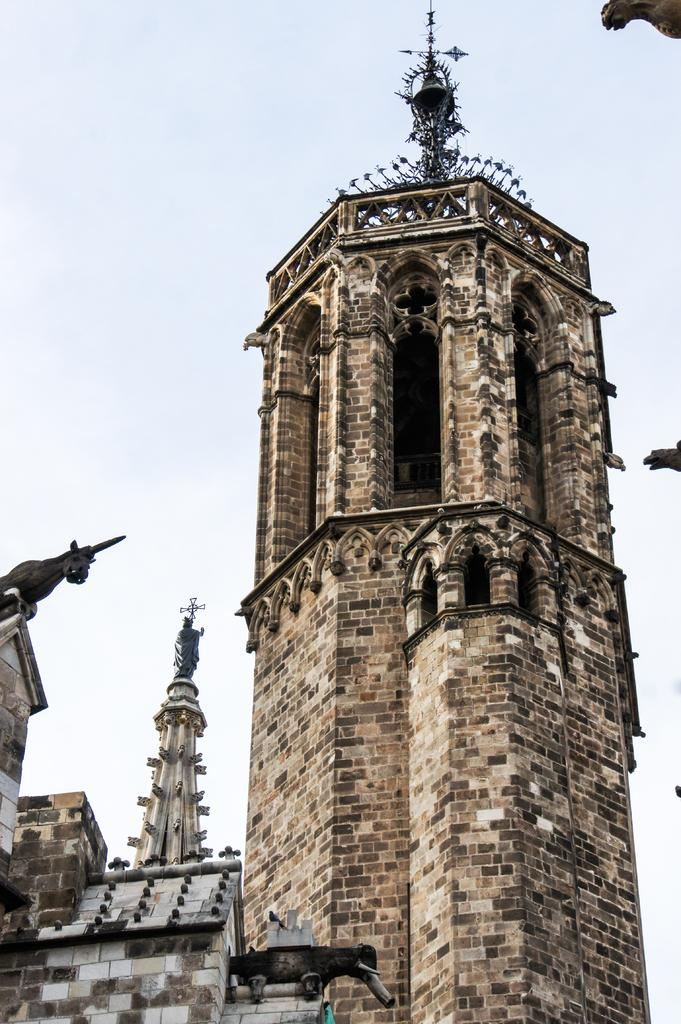What type of structures can be seen in the image? There are buildings in the image. Are there any additional features on top of the buildings? Yes, there are statues on top of the buildings. What type of cast is visible on the building in the image? There is no cast visible on the building in the image. How many times does the statue sneeze in the image? There are no actions or sounds depicted in the image, so it is impossible to determine if the statue sneezes. 